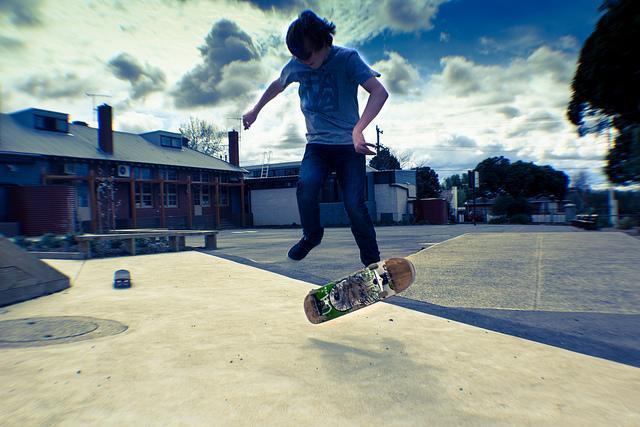How many skateboards are in the picture?
Give a very brief answer. 1. 